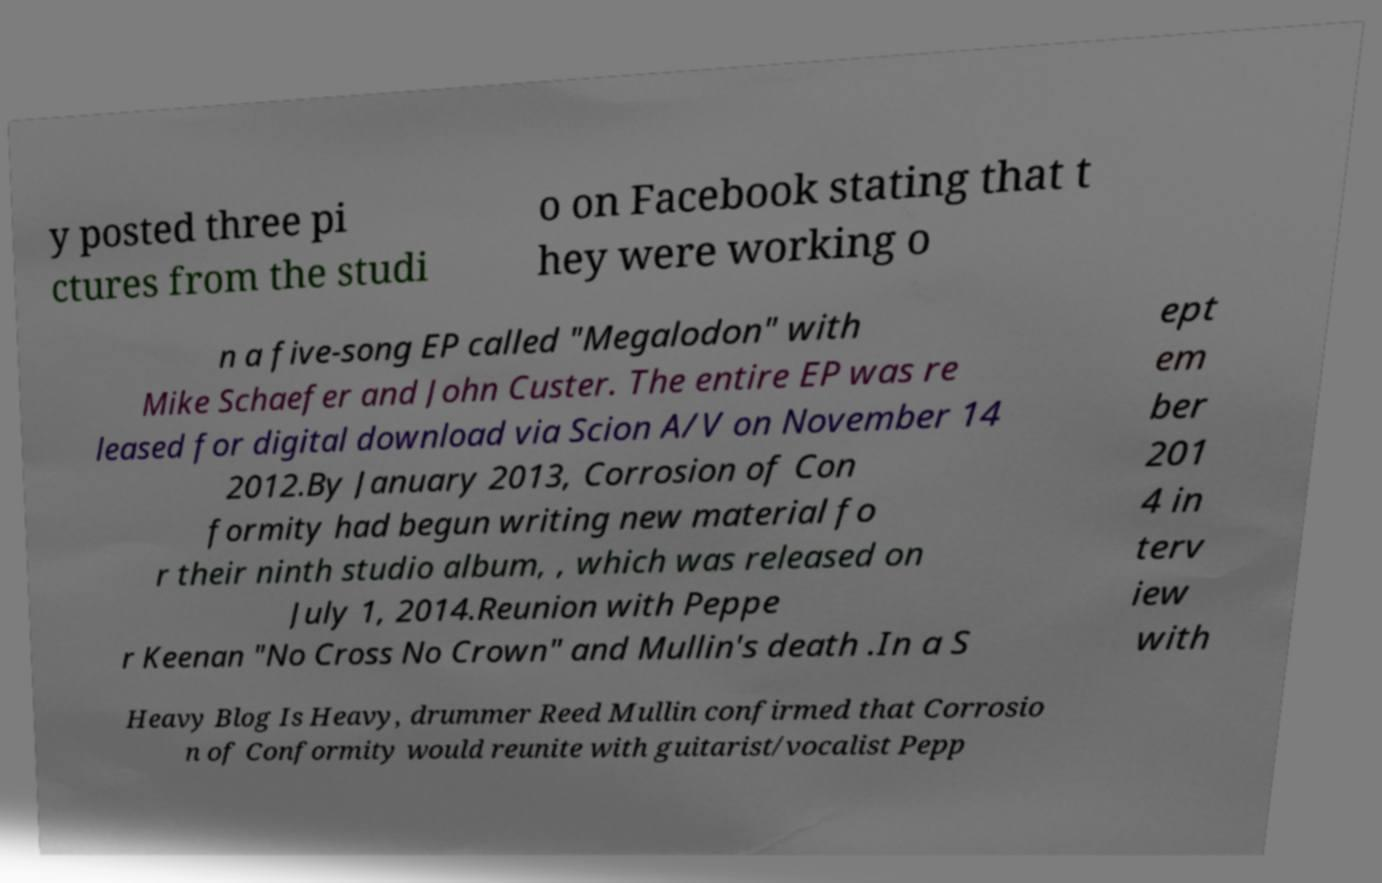Could you extract and type out the text from this image? y posted three pi ctures from the studi o on Facebook stating that t hey were working o n a five-song EP called "Megalodon" with Mike Schaefer and John Custer. The entire EP was re leased for digital download via Scion A/V on November 14 2012.By January 2013, Corrosion of Con formity had begun writing new material fo r their ninth studio album, , which was released on July 1, 2014.Reunion with Peppe r Keenan "No Cross No Crown" and Mullin's death .In a S ept em ber 201 4 in terv iew with Heavy Blog Is Heavy, drummer Reed Mullin confirmed that Corrosio n of Conformity would reunite with guitarist/vocalist Pepp 